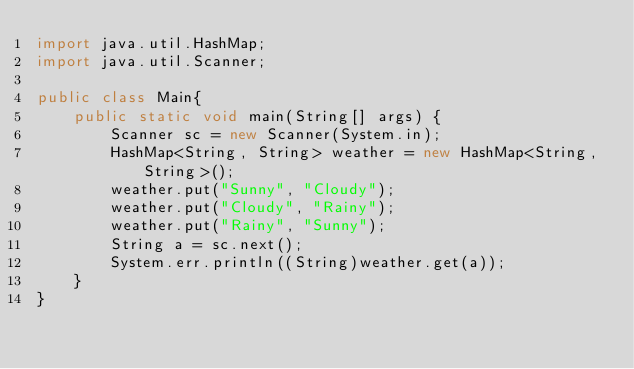Convert code to text. <code><loc_0><loc_0><loc_500><loc_500><_Java_>import java.util.HashMap;
import java.util.Scanner;

public class Main{
    public static void main(String[] args) {
        Scanner sc = new Scanner(System.in);
        HashMap<String, String> weather = new HashMap<String, String>();
        weather.put("Sunny", "Cloudy");
        weather.put("Cloudy", "Rainy");
        weather.put("Rainy", "Sunny");
        String a = sc.next();
        System.err.println((String)weather.get(a));
    }
}</code> 